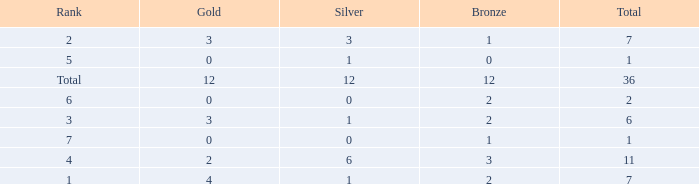What is the number of bronze medals when there are fewer than 0 silver medals? None. 